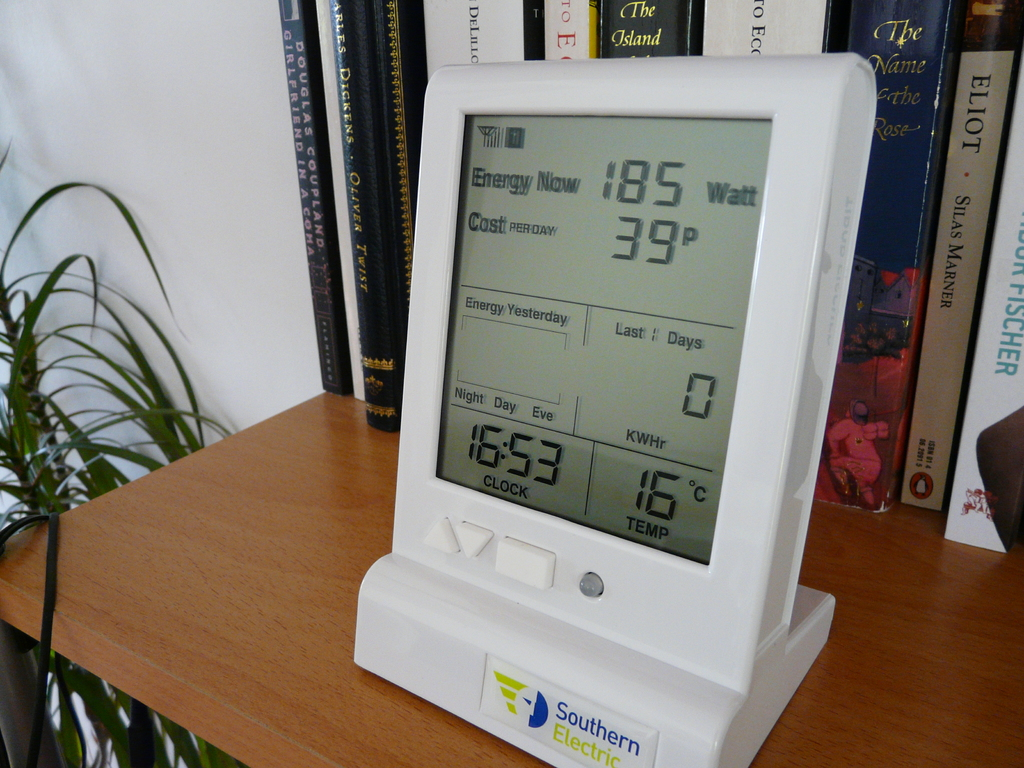Can you explain what the terms 'Day', 'Night', and 'Eve' mean on the energy monitor? These terms on the energy monitor represent different time periods during which energy tariffs vary. 'Day' usually denotes peak hours when energy rates are higher due to increased demand. 'Night' refers to off-peak hours when less energy is being consumed, and rates are generally lower. 'Eve' could indicate evening time, a period which can either be considered peak or off-peak depending on the energy supplier’s policy. This differentiated tariff system encourages consumers to adjust their electricity usage based on the cost incentives, potentially saving money and reducing energy consumption during peak periods. 